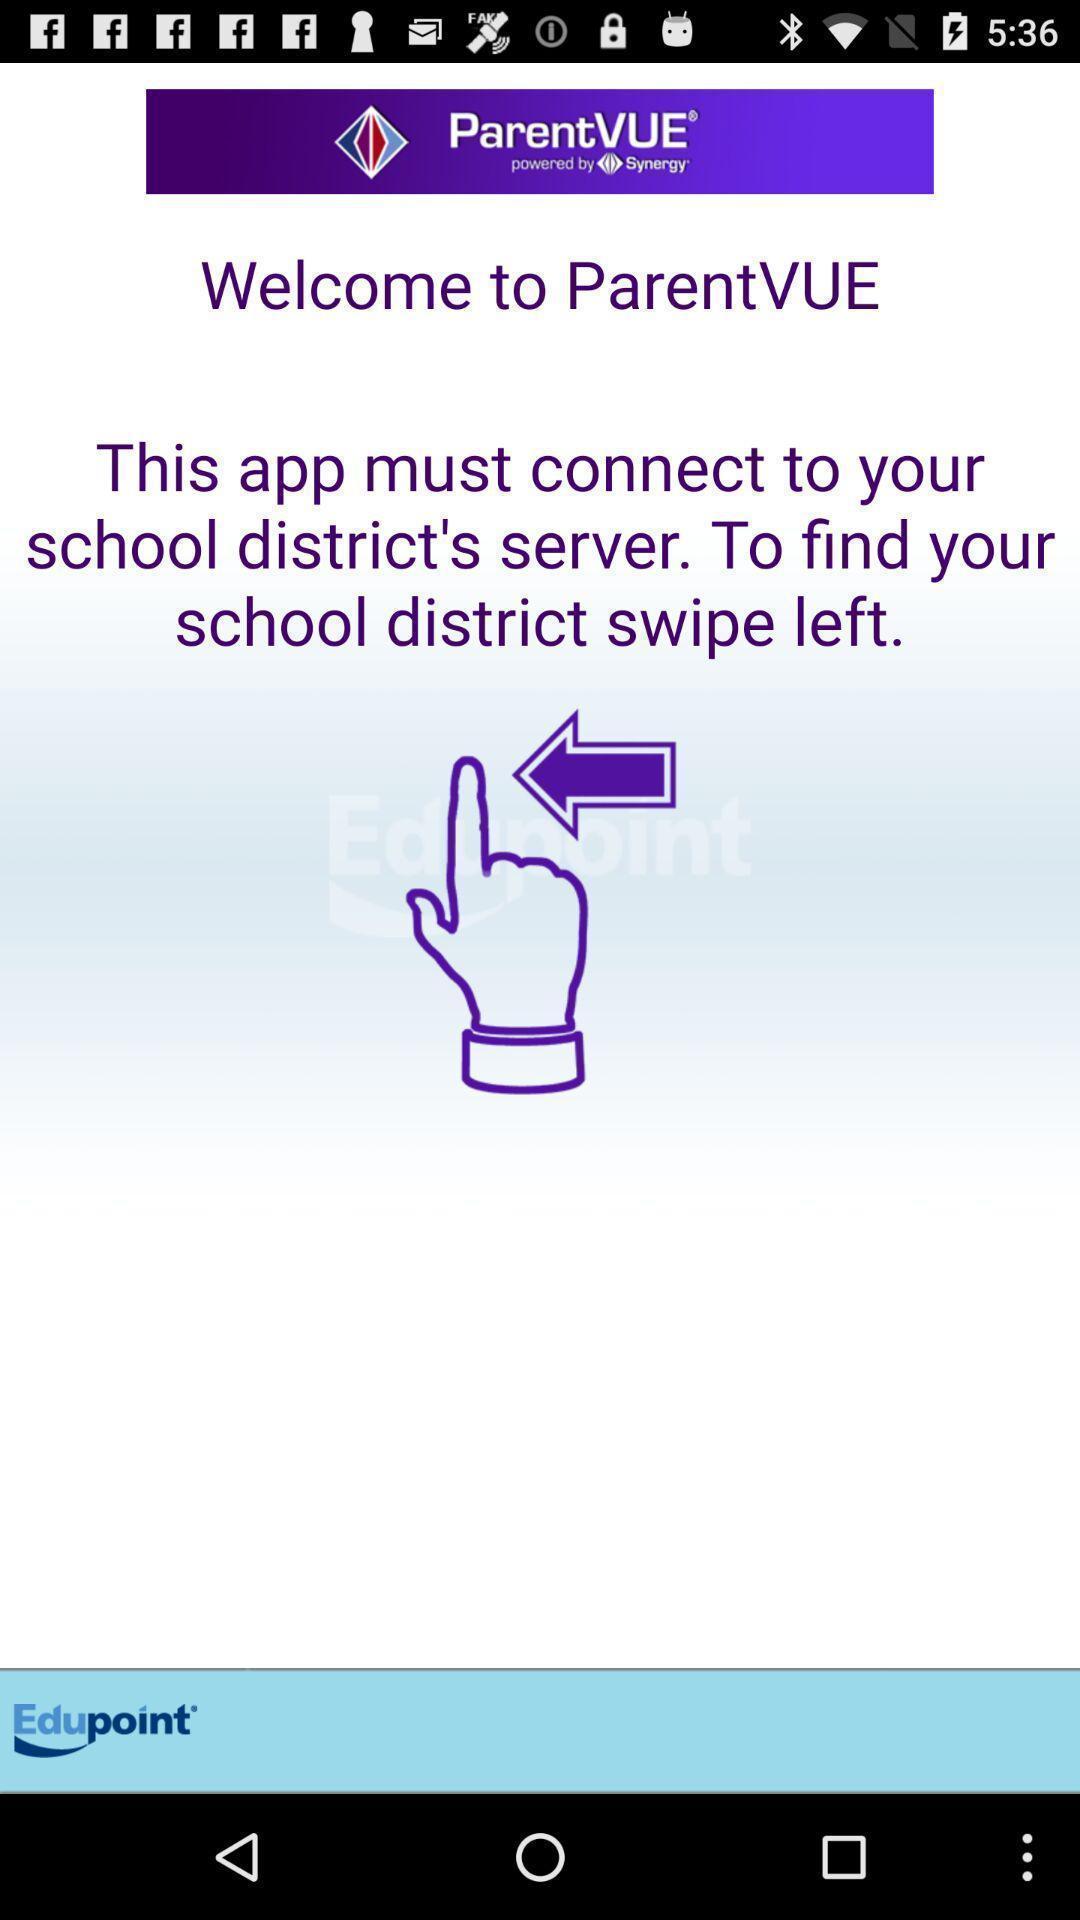Describe this image in words. Welcome page of an educational app. 